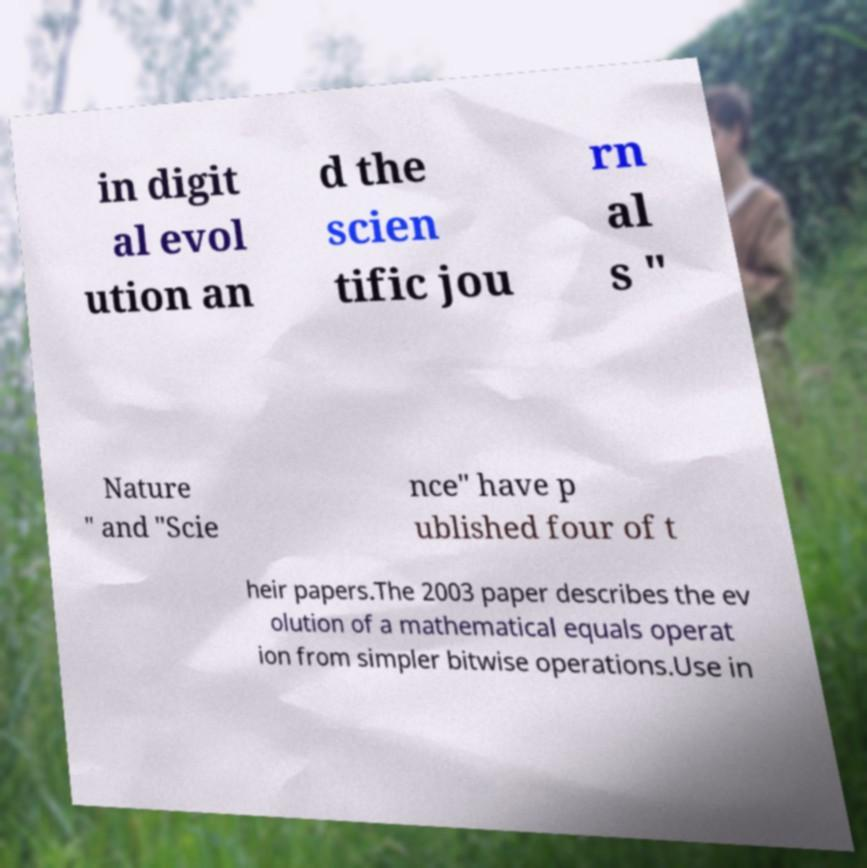I need the written content from this picture converted into text. Can you do that? in digit al evol ution an d the scien tific jou rn al s " Nature " and "Scie nce" have p ublished four of t heir papers.The 2003 paper describes the ev olution of a mathematical equals operat ion from simpler bitwise operations.Use in 